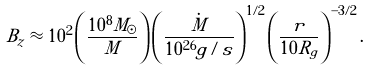<formula> <loc_0><loc_0><loc_500><loc_500>B _ { z } \approx 1 0 ^ { 2 } \left ( \frac { 1 0 ^ { 8 } M _ { \odot } } { M } \right ) \left ( \frac { \dot { M } } { 1 0 ^ { 2 6 } g / s } \right ) ^ { 1 / 2 } \left ( \frac { r } { 1 0 R _ { g } } \right ) ^ { - 3 / 2 } .</formula> 